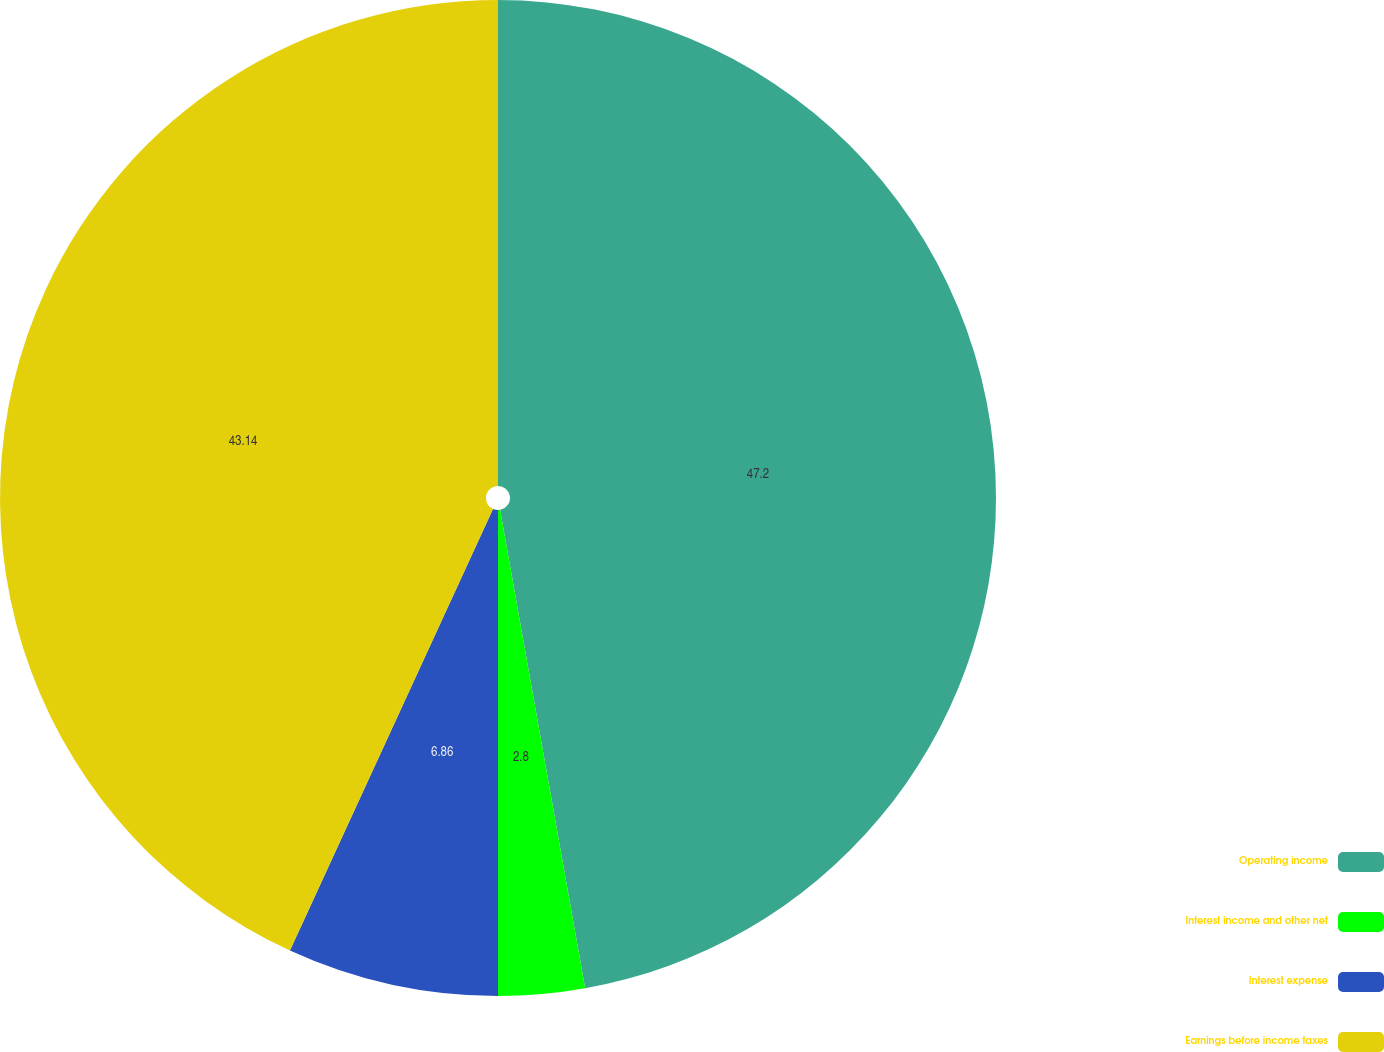Convert chart. <chart><loc_0><loc_0><loc_500><loc_500><pie_chart><fcel>Operating income<fcel>Interest income and other net<fcel>Interest expense<fcel>Earnings before income taxes<nl><fcel>47.2%<fcel>2.8%<fcel>6.86%<fcel>43.14%<nl></chart> 